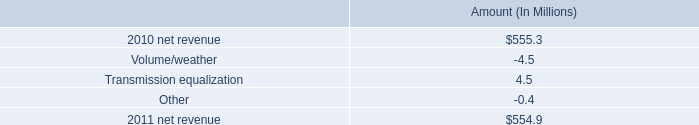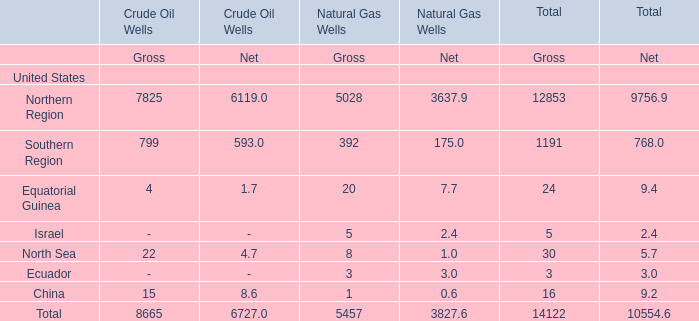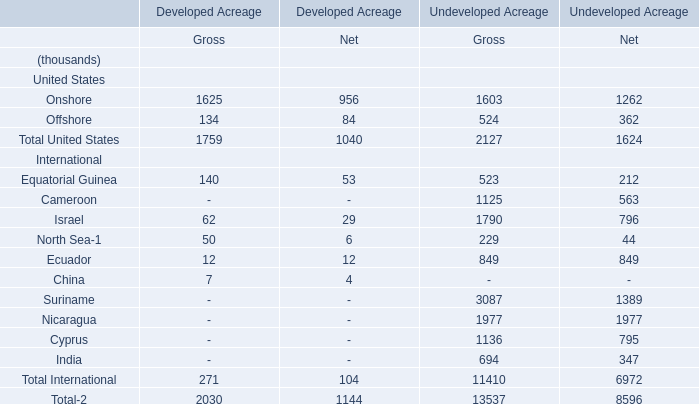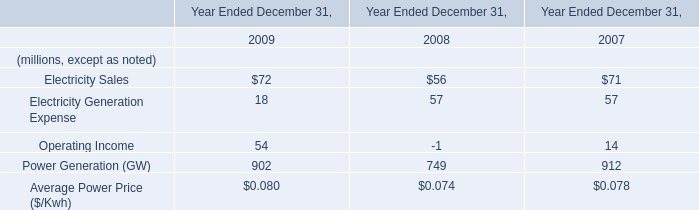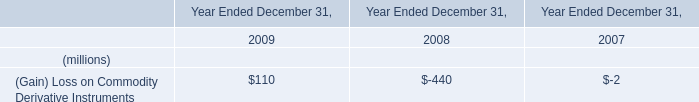What's the sum of Onshore of Developed Acreage Gross, and Northern Region of Natural Gas Wells Net ? 
Computations: (1625.0 + 3637.9)
Answer: 5262.9. 